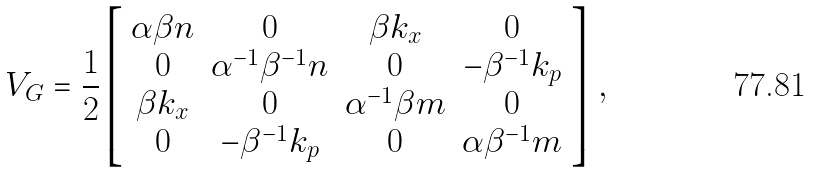Convert formula to latex. <formula><loc_0><loc_0><loc_500><loc_500>V _ { G } = \frac { 1 } { 2 } \left [ \begin{array} { c c c c } \alpha \beta n & 0 & \beta k _ { x } & 0 \\ 0 & { \alpha } ^ { - 1 } { \beta } ^ { - 1 } n & 0 & - { \beta } ^ { - 1 } k _ { p } \\ \beta k _ { x } & 0 & { \alpha } ^ { - 1 } \beta m & 0 \\ 0 & - { \beta } ^ { - 1 } k _ { p } & 0 & \alpha { \beta } ^ { - 1 } m \\ \end{array} \right ] \, ,</formula> 